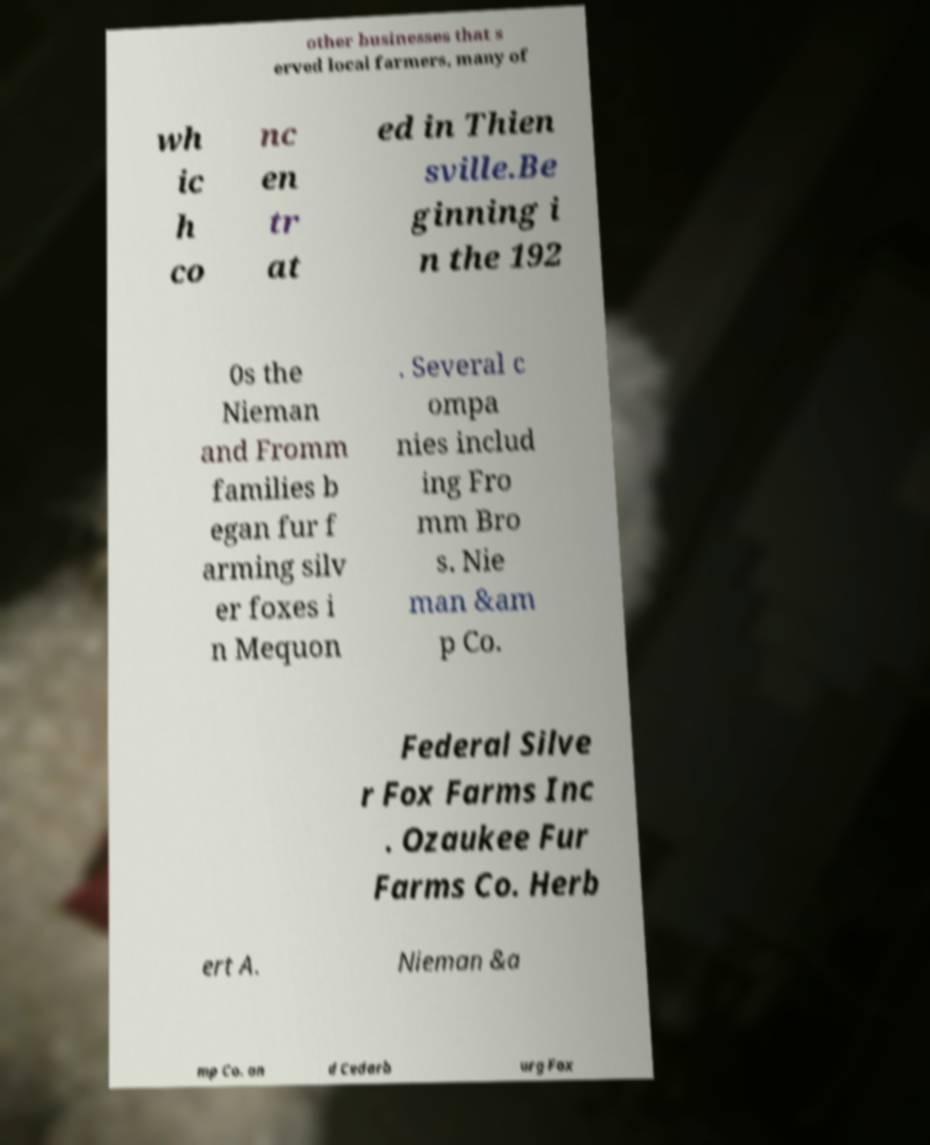Can you accurately transcribe the text from the provided image for me? other businesses that s erved local farmers, many of wh ic h co nc en tr at ed in Thien sville.Be ginning i n the 192 0s the Nieman and Fromm families b egan fur f arming silv er foxes i n Mequon . Several c ompa nies includ ing Fro mm Bro s. Nie man &am p Co. Federal Silve r Fox Farms Inc . Ozaukee Fur Farms Co. Herb ert A. Nieman &a mp Co. an d Cedarb urg Fox 